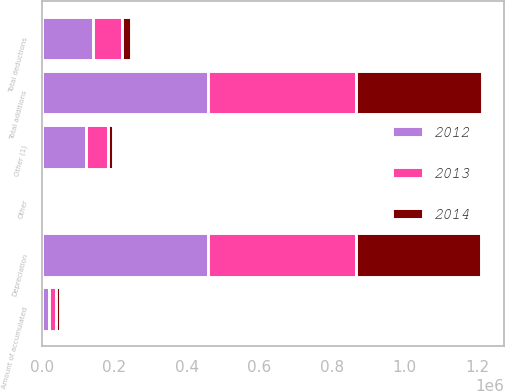Convert chart to OTSL. <chart><loc_0><loc_0><loc_500><loc_500><stacked_bar_chart><ecel><fcel>Depreciation<fcel>Other<fcel>Total additions<fcel>Amount of accumulated<fcel>Other (1)<fcel>Total deductions<nl><fcel>2012<fcel>457135<fcel>761<fcel>457896<fcel>20953<fcel>120898<fcel>141851<nl><fcel>2013<fcel>408693<fcel>264<fcel>408957<fcel>17462<fcel>62692<fcel>80154<nl><fcel>2014<fcel>344778<fcel>253<fcel>345031<fcel>10920<fcel>12808<fcel>23728<nl></chart> 